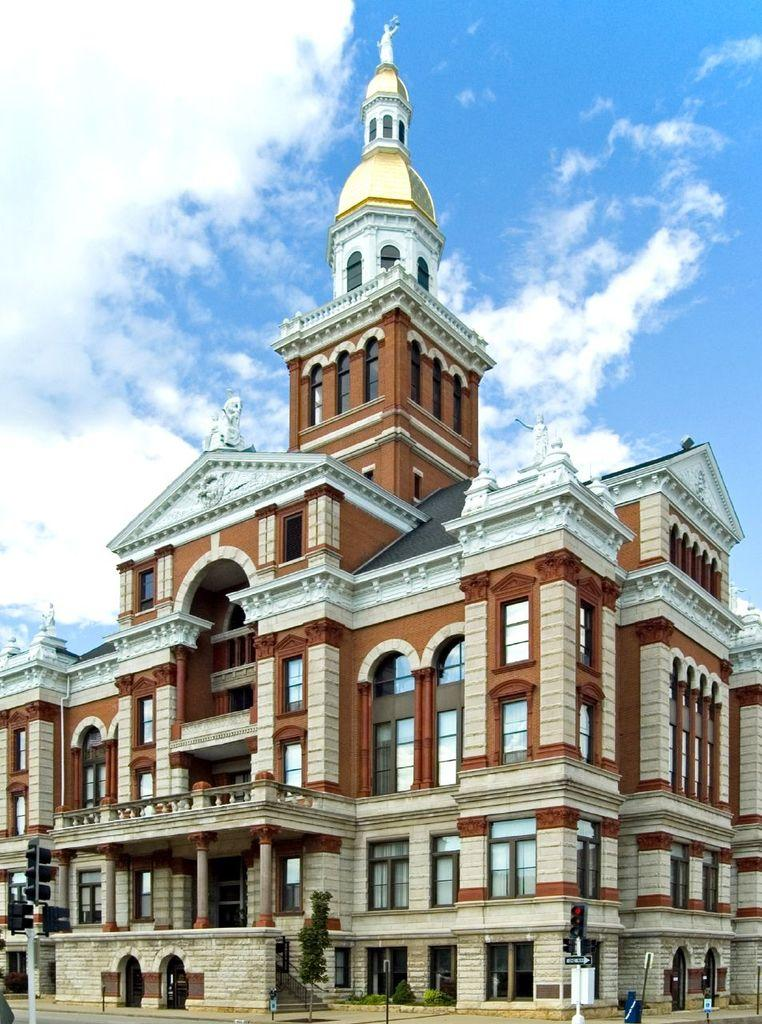What is the color of the building in the image? The building in the image is brown-colored. What can be seen in the sky at the top of the image? There are clouds visible in the sky at the top of the image. What architectural features does the building have? The building has many windows, a door, and pillars. What type of silver net is draped over the building in the image? There is no silver net present in the image; the building has windows, a door, and pillars. 